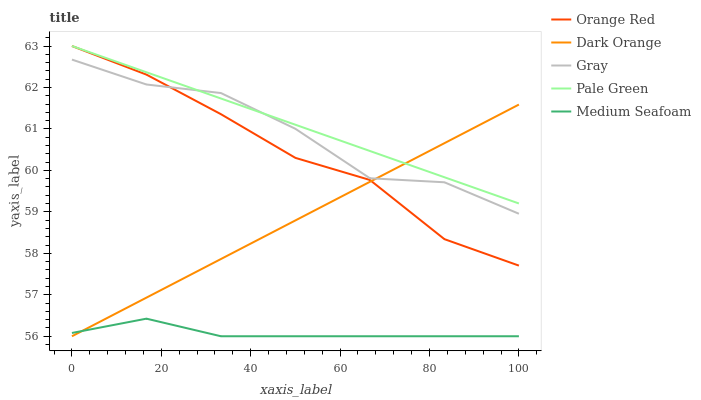Does Medium Seafoam have the minimum area under the curve?
Answer yes or no. Yes. Does Pale Green have the maximum area under the curve?
Answer yes or no. Yes. Does Pale Green have the minimum area under the curve?
Answer yes or no. No. Does Medium Seafoam have the maximum area under the curve?
Answer yes or no. No. Is Pale Green the smoothest?
Answer yes or no. Yes. Is Gray the roughest?
Answer yes or no. Yes. Is Medium Seafoam the smoothest?
Answer yes or no. No. Is Medium Seafoam the roughest?
Answer yes or no. No. Does Dark Orange have the lowest value?
Answer yes or no. Yes. Does Pale Green have the lowest value?
Answer yes or no. No. Does Orange Red have the highest value?
Answer yes or no. Yes. Does Medium Seafoam have the highest value?
Answer yes or no. No. Is Medium Seafoam less than Gray?
Answer yes or no. Yes. Is Orange Red greater than Medium Seafoam?
Answer yes or no. Yes. Does Dark Orange intersect Medium Seafoam?
Answer yes or no. Yes. Is Dark Orange less than Medium Seafoam?
Answer yes or no. No. Is Dark Orange greater than Medium Seafoam?
Answer yes or no. No. Does Medium Seafoam intersect Gray?
Answer yes or no. No. 